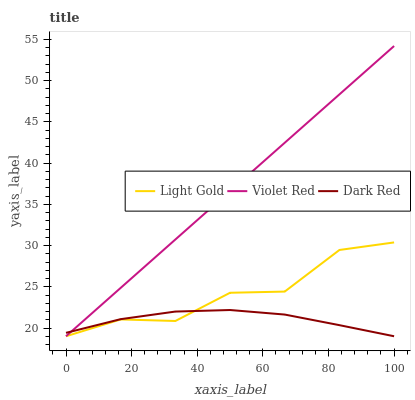Does Dark Red have the minimum area under the curve?
Answer yes or no. Yes. Does Violet Red have the maximum area under the curve?
Answer yes or no. Yes. Does Light Gold have the minimum area under the curve?
Answer yes or no. No. Does Light Gold have the maximum area under the curve?
Answer yes or no. No. Is Violet Red the smoothest?
Answer yes or no. Yes. Is Light Gold the roughest?
Answer yes or no. Yes. Is Light Gold the smoothest?
Answer yes or no. No. Is Violet Red the roughest?
Answer yes or no. No. Does Dark Red have the lowest value?
Answer yes or no. Yes. Does Violet Red have the highest value?
Answer yes or no. Yes. Does Light Gold have the highest value?
Answer yes or no. No. Does Light Gold intersect Violet Red?
Answer yes or no. Yes. Is Light Gold less than Violet Red?
Answer yes or no. No. Is Light Gold greater than Violet Red?
Answer yes or no. No. 